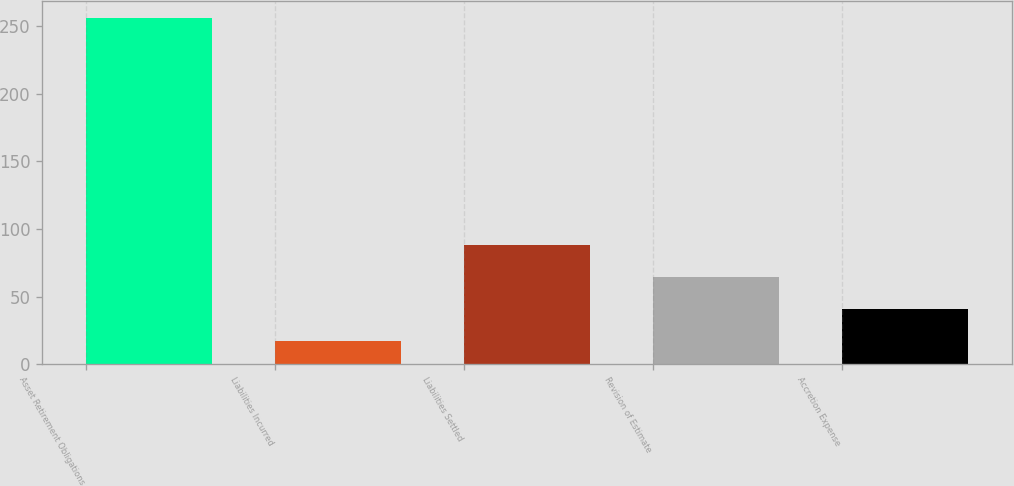Convert chart. <chart><loc_0><loc_0><loc_500><loc_500><bar_chart><fcel>Asset Retirement Obligations<fcel>Liabilities Incurred<fcel>Liabilities Settled<fcel>Revision of Estimate<fcel>Accretion Expense<nl><fcel>255.6<fcel>17<fcel>87.8<fcel>64.2<fcel>40.6<nl></chart> 